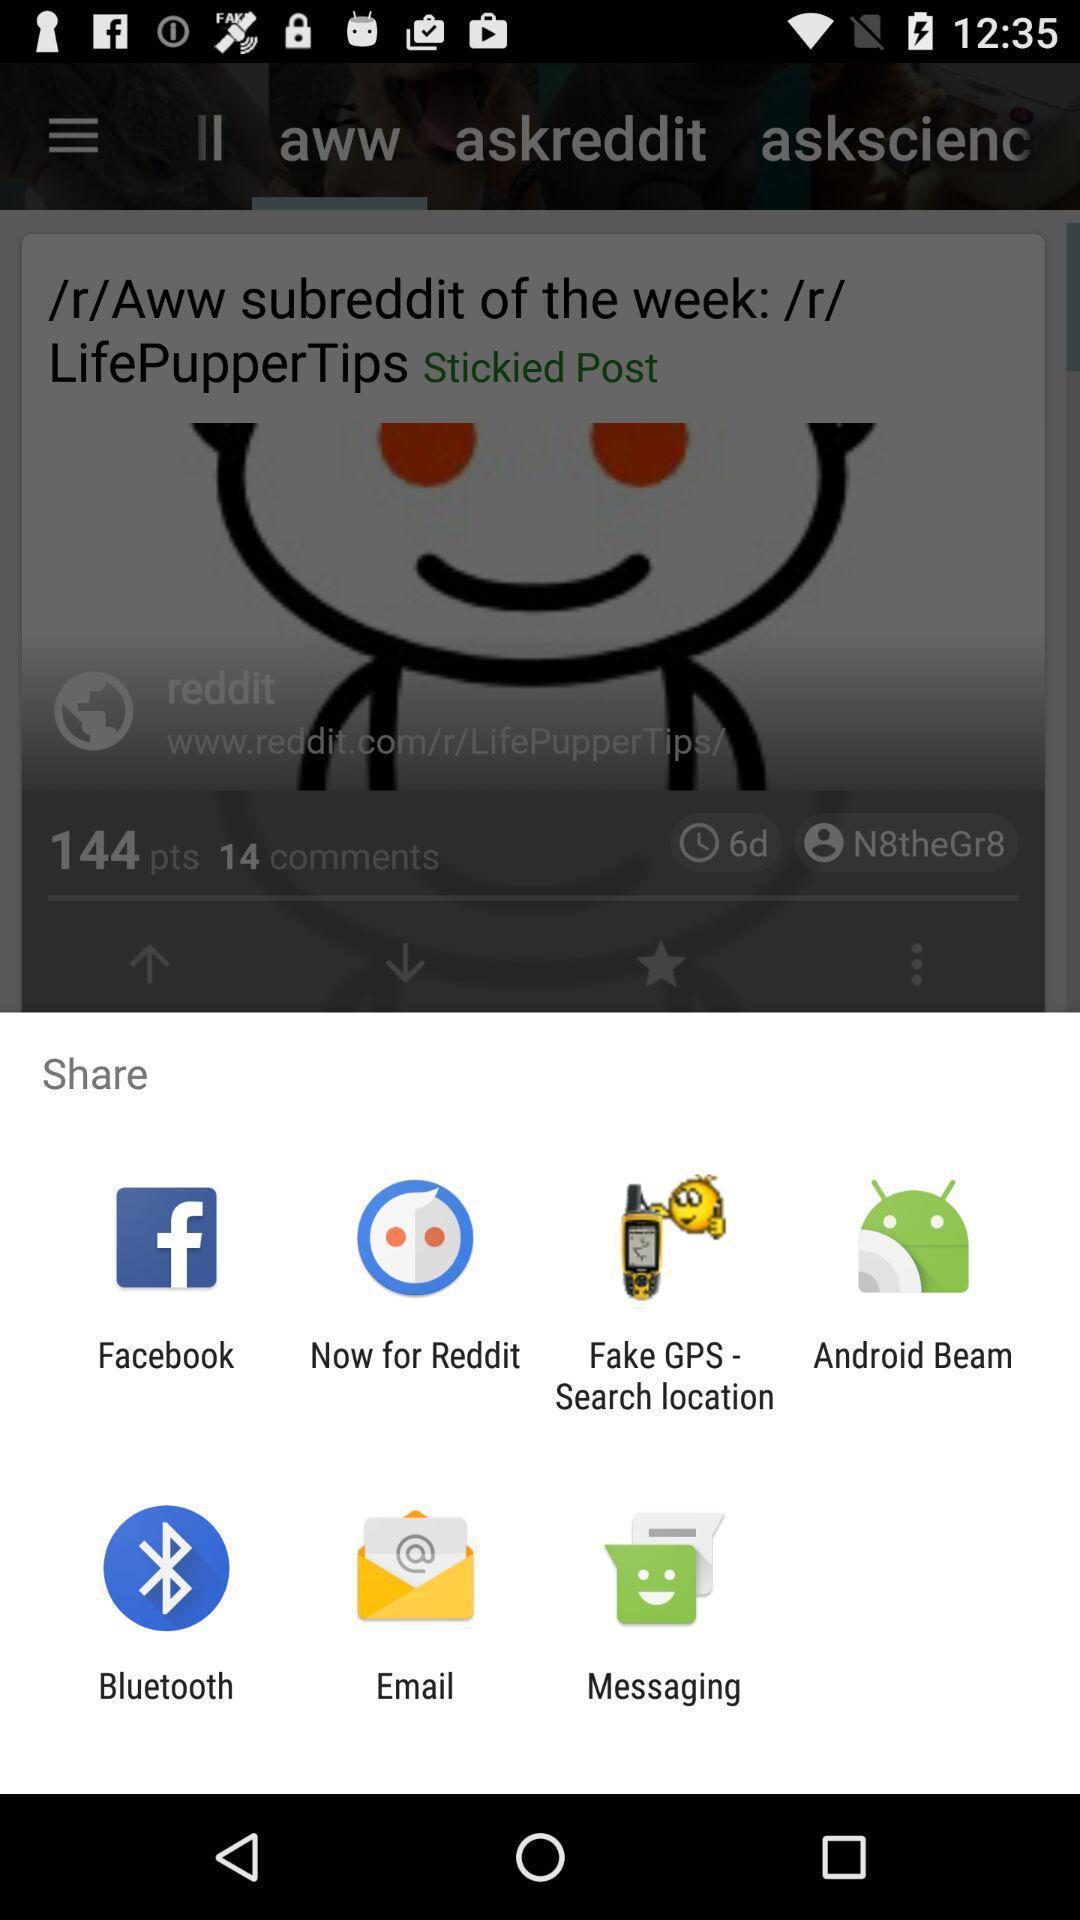Provide a textual representation of this image. Pop-up is showing different social apps and data sharing apps. 